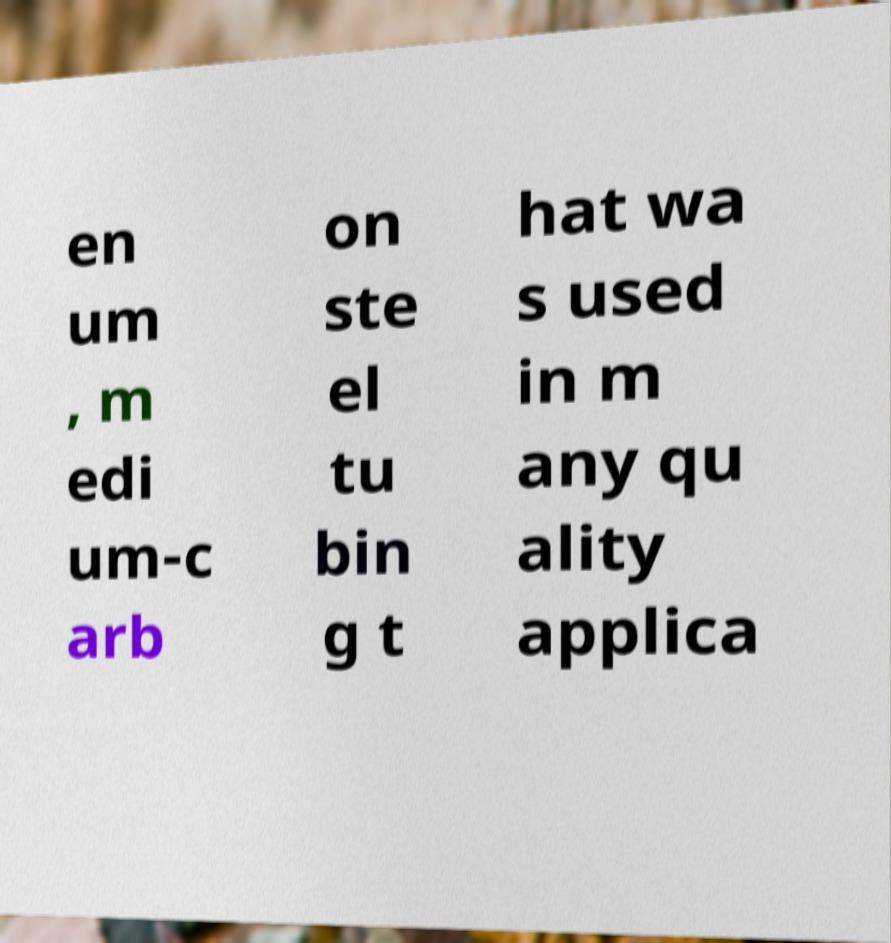Could you assist in decoding the text presented in this image and type it out clearly? en um , m edi um-c arb on ste el tu bin g t hat wa s used in m any qu ality applica 